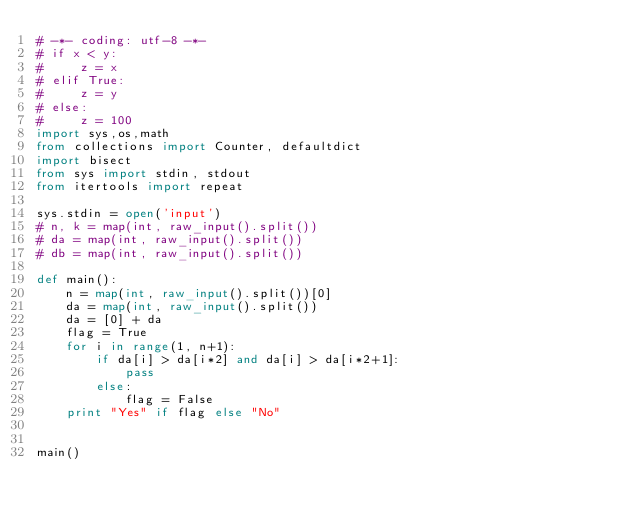<code> <loc_0><loc_0><loc_500><loc_500><_Python_># -*- coding: utf-8 -*-
# if x < y:
#     z = x
# elif True:
#     z = y
# else:
#     z = 100
import sys,os,math
from collections import Counter, defaultdict
import bisect
from sys import stdin, stdout
from itertools import repeat

sys.stdin = open('input')
# n, k = map(int, raw_input().split())
# da = map(int, raw_input().split())
# db = map(int, raw_input().split())

def main():
    n = map(int, raw_input().split())[0]
    da = map(int, raw_input().split())
    da = [0] + da
    flag = True
    for i in range(1, n+1):
        if da[i] > da[i*2] and da[i] > da[i*2+1]:
            pass
        else:
            flag = False
    print "Yes" if flag else "No"


main()
</code> 